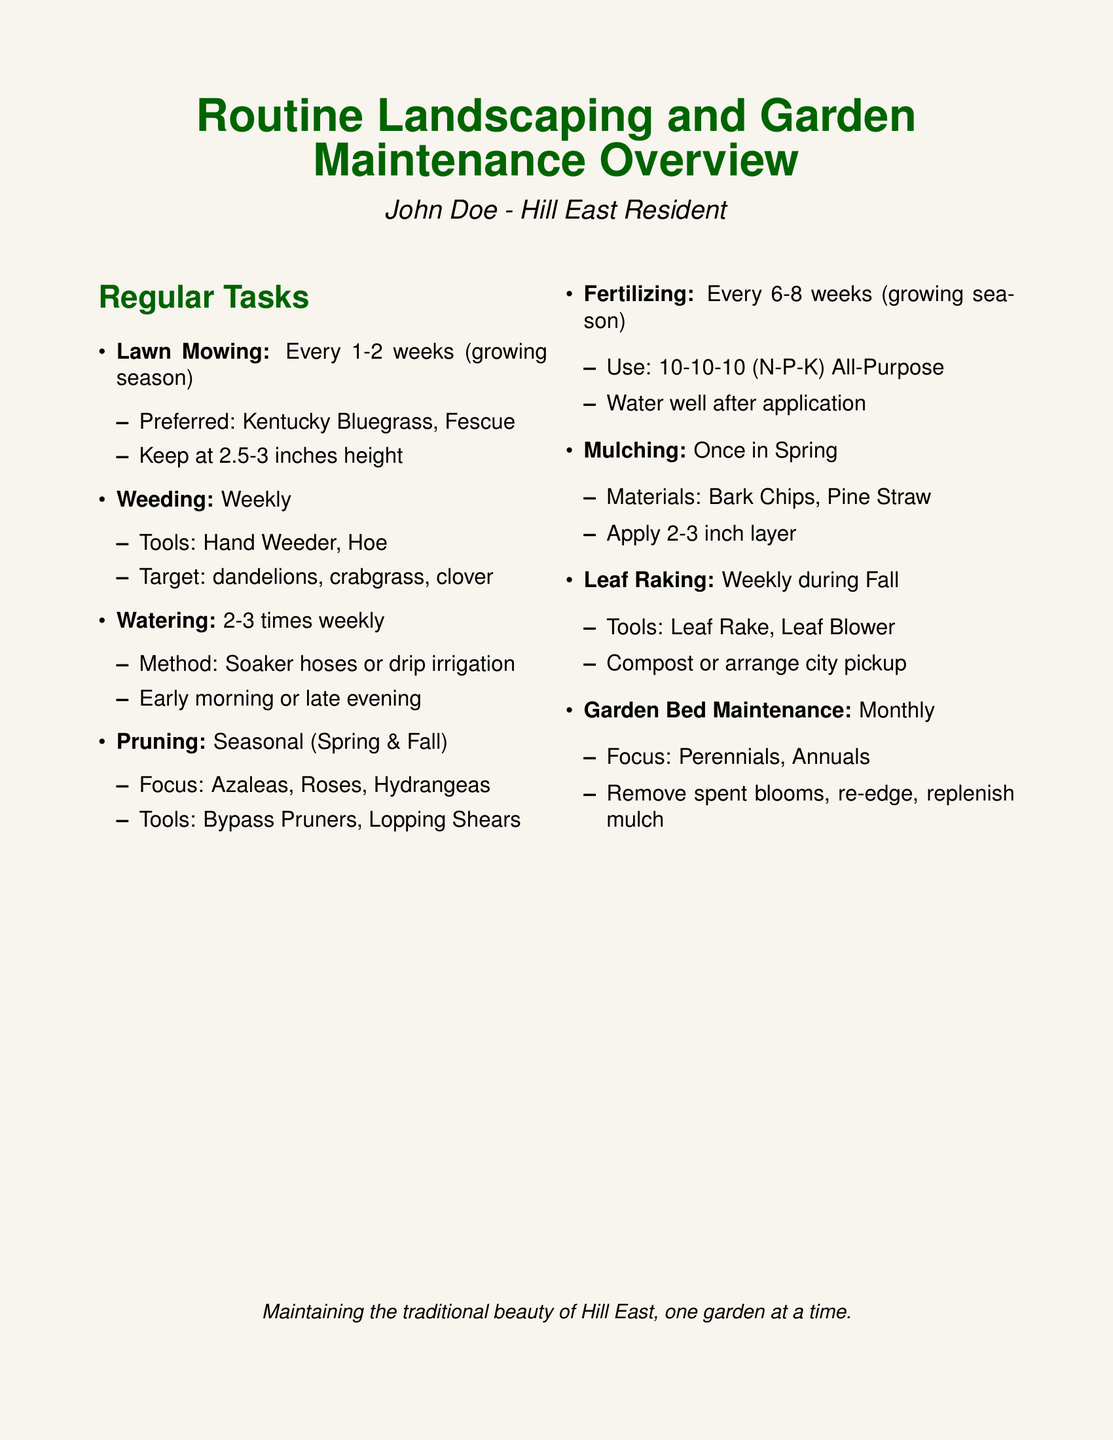What is the frequency of lawn mowing? The document states that lawn mowing occurs every 1-2 weeks during the growing season.
Answer: Every 1-2 weeks What height should the lawn be kept at? The document specifies that the lawn should be kept at a height of 2.5-3 inches.
Answer: 2.5-3 inches How often should weeding be done? The maintenance log indicates that weeding should be done weekly.
Answer: Weekly What tools are used for weeding? According to the document, the tools used for weeding include a hand weeder and a hoe.
Answer: Hand Weeder, Hoe When should pruning be performed? The document states that pruning should be done in the spring and fall.
Answer: Spring & Fall What is the recommended fertilizer interval? The maintenance log mentions that fertilizing should occur every 6-8 weeks during the growing season.
Answer: Every 6-8 weeks How often is leaf raking needed? The document specifies that leaf raking should be done weekly during fall.
Answer: Weekly during Fall What is the focus of garden bed maintenance? The document lists that garden bed maintenance focuses on perennials and annuals.
Answer: Perennials, Annuals 